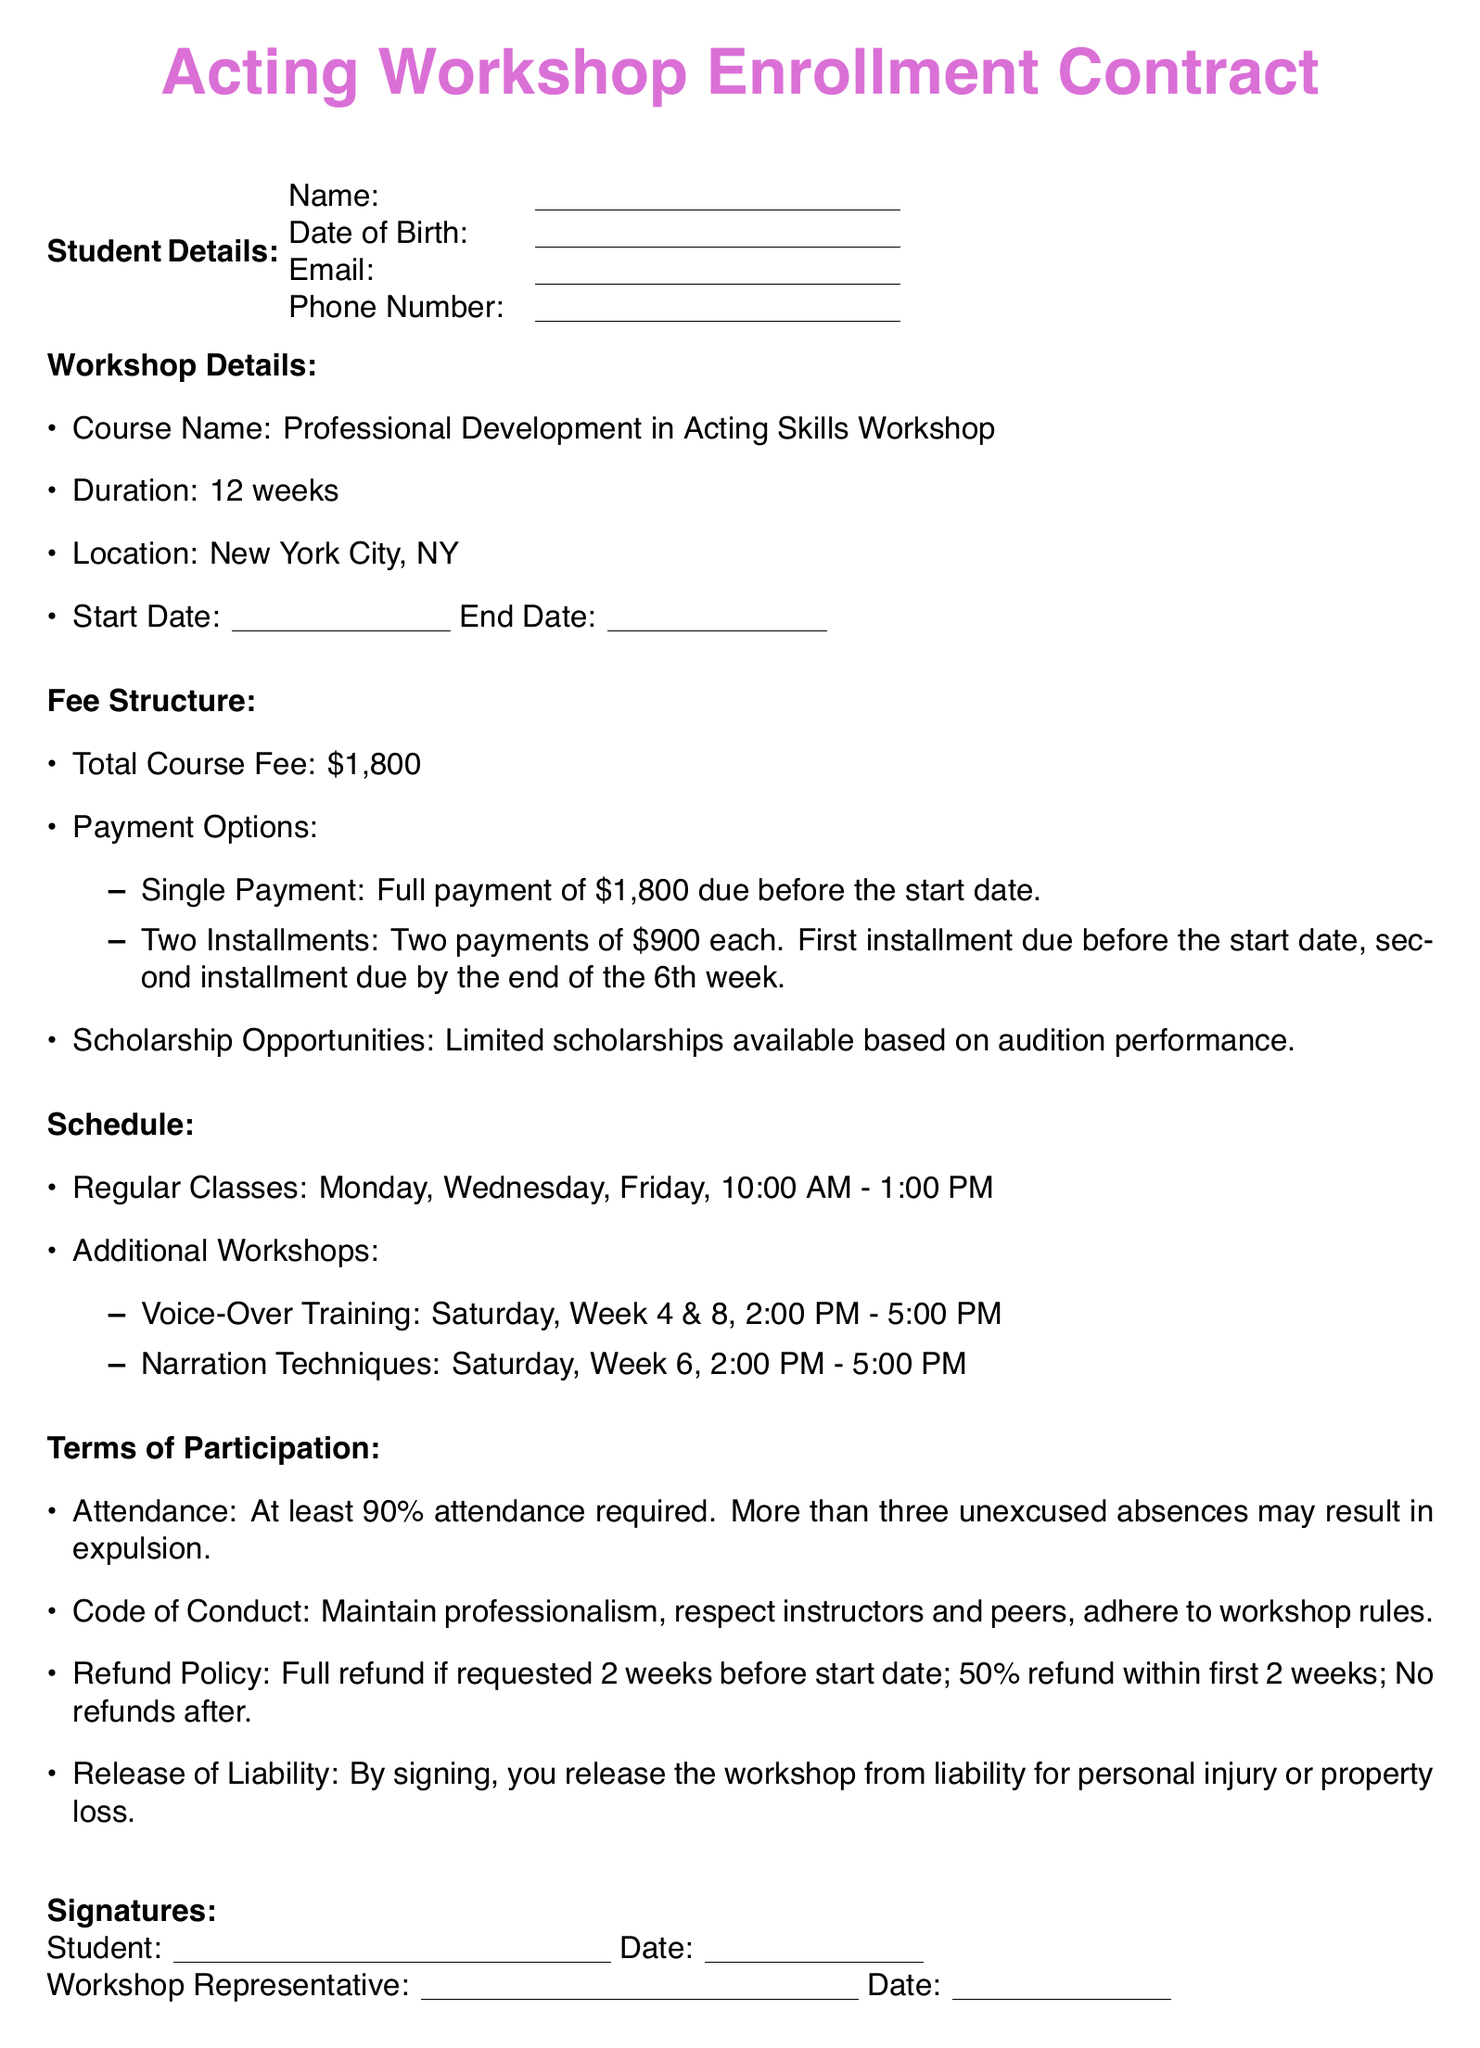What is the course name? The course name is stated clearly in the document as the title of the workshop.
Answer: Professional Development in Acting Skills Workshop What is the total course fee? The total course fee is specified under the Fee Structure section.
Answer: $1,800 How long is the duration of the workshop? The duration is explicitly mentioned in the workshop details.
Answer: 12 weeks When are the regular classes held? The timing of the regular classes is detailed in the Schedule section of the document.
Answer: Monday, Wednesday, Friday, 10:00 AM - 1:00 PM How many unexcused absences can result in expulsion? The terms of participation outline the consequences of attendance in the document.
Answer: More than three What is the refund policy if requested 2 weeks before the start date? The refund policy provides specific conditions regarding refunds based on timing in the document.
Answer: Full refund What are the additional workshop topics offered? Additional workshops are listed in the schedule, providing their specific topics.
Answer: Voice-Over Training, Narration Techniques What are the payment options for the course fee? The payment options are clearly described under Fee Structure in the document.
Answer: Single Payment, Two Installments What is the location of the workshop? The location is specified in the workshop details section of the document.
Answer: New York City, NY 